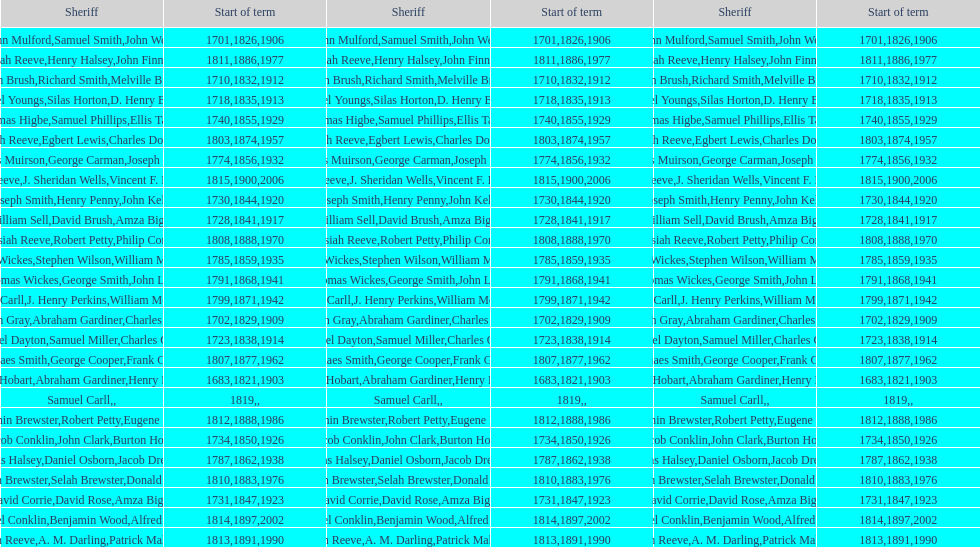Did robert petty serve before josiah reeve? No. 